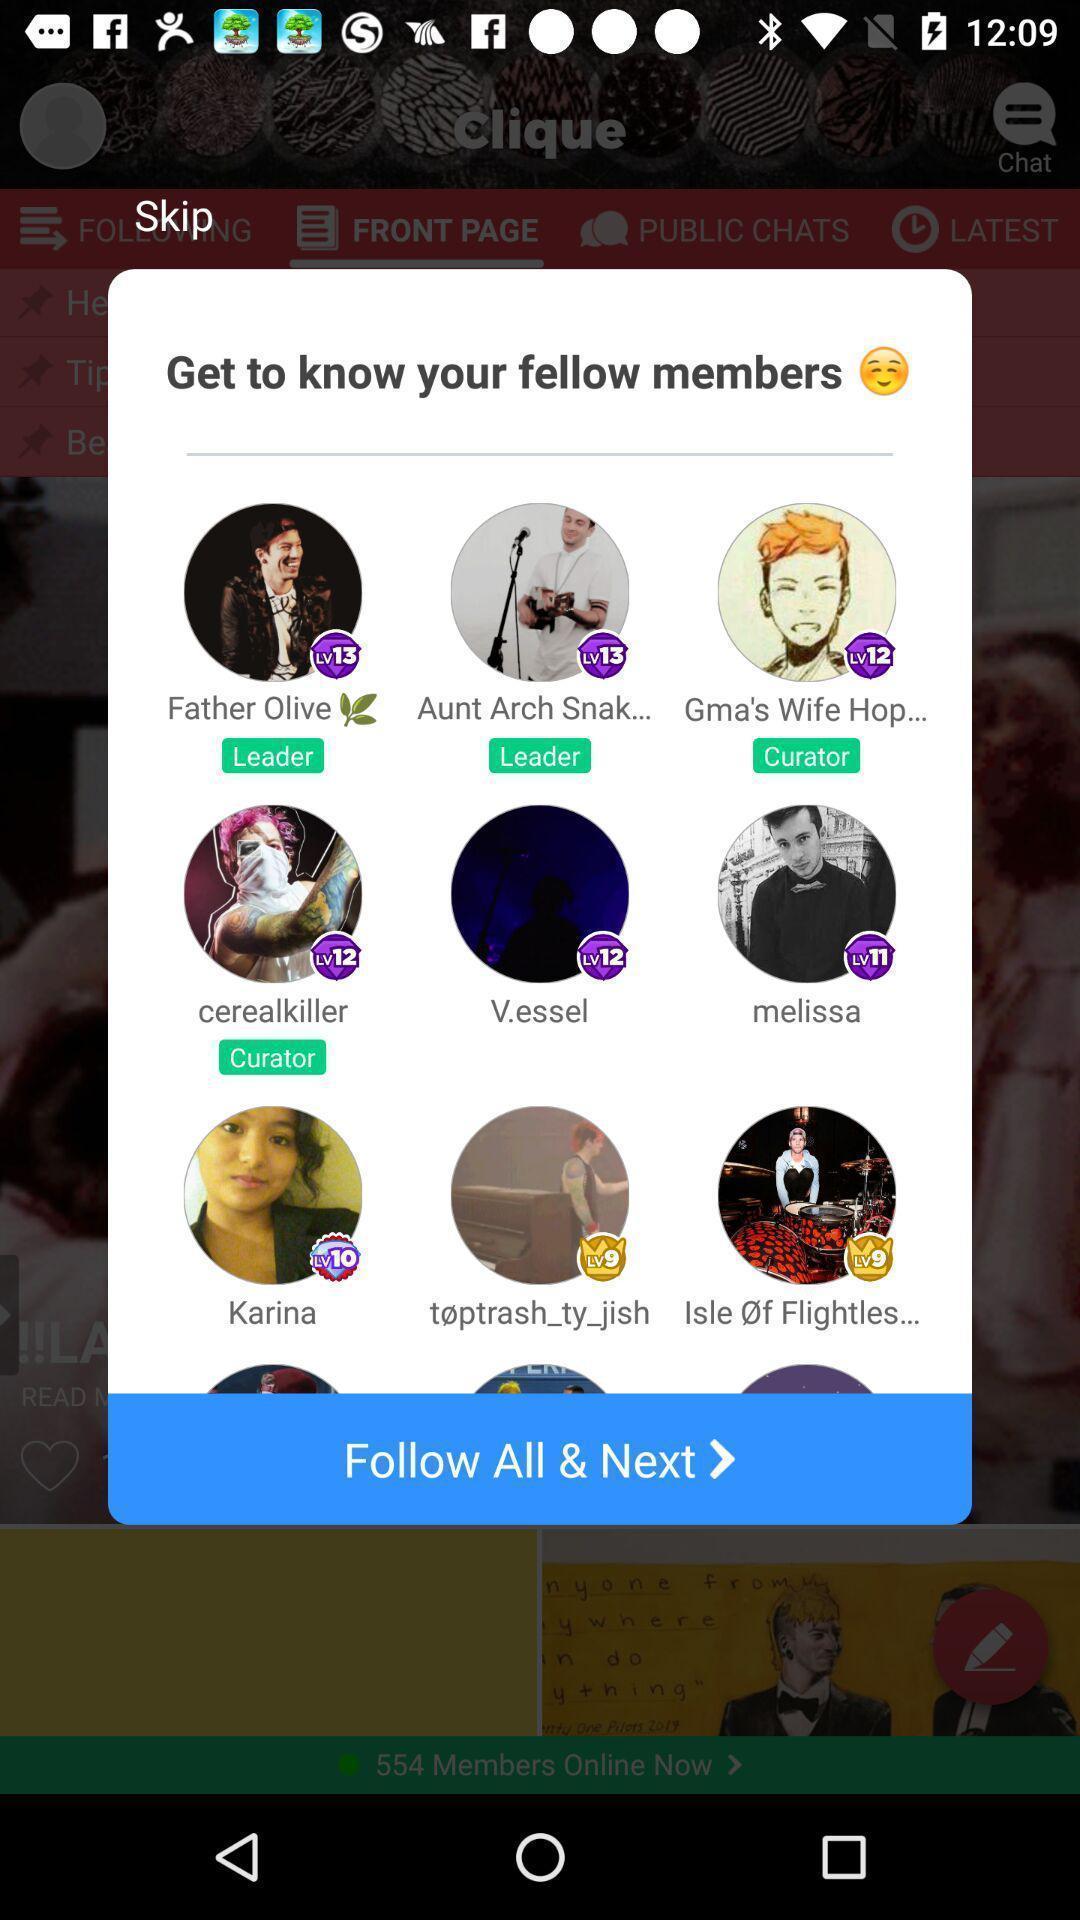Please provide a description for this image. Pop-up suggesting the fellow members to follow. 